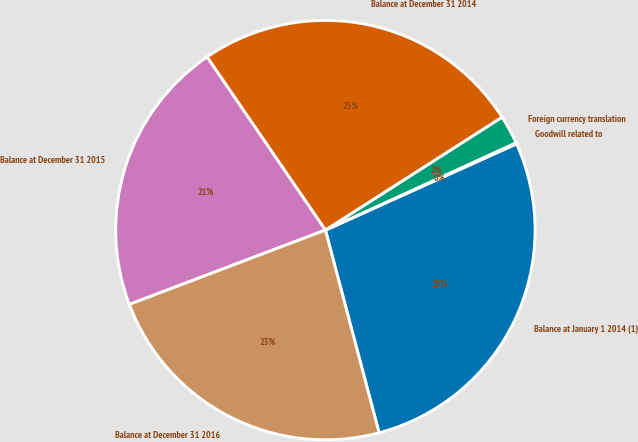Convert chart to OTSL. <chart><loc_0><loc_0><loc_500><loc_500><pie_chart><fcel>Balance at January 1 2014 (1)<fcel>Goodwill related to<fcel>Foreign currency translation<fcel>Balance at December 31 2014<fcel>Balance at December 31 2015<fcel>Balance at December 31 2016<nl><fcel>27.62%<fcel>0.09%<fcel>2.22%<fcel>25.49%<fcel>21.22%<fcel>23.35%<nl></chart> 